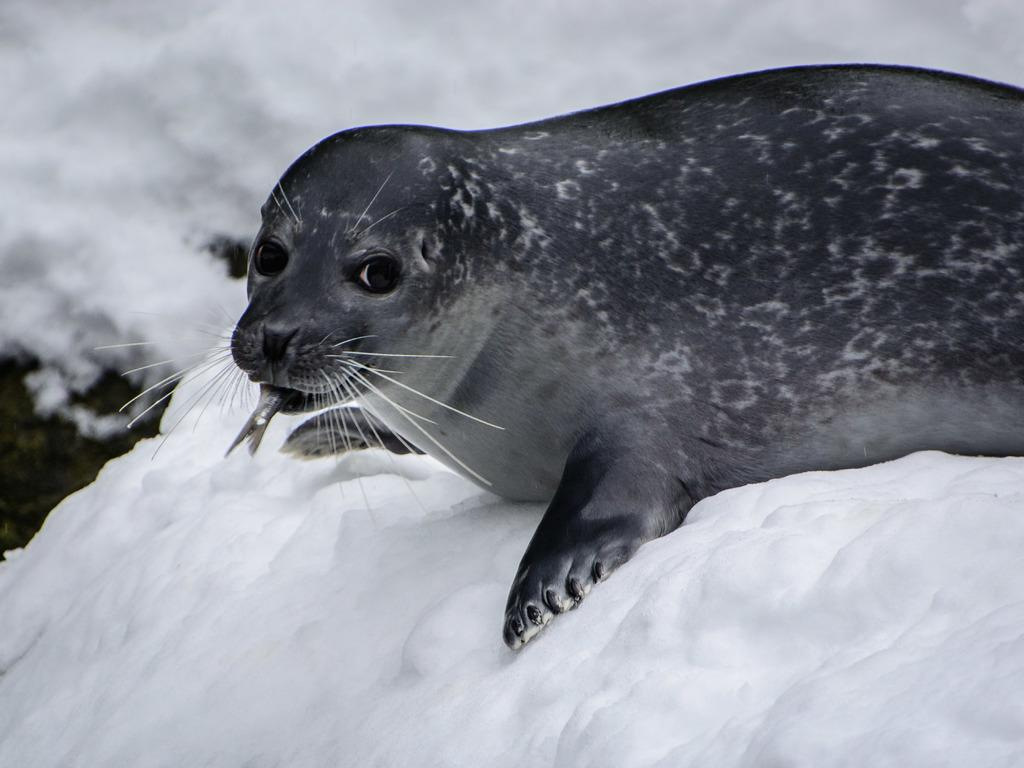What is the main subject of the picture? There is a seal in the middle of the picture. What is located at the bottom of the picture? There is ice at the bottom of the picture. What color is the background of the image? The background of the image is white in color. Is the image in color or black and white? The image is in black and white. Can you see a scarf being worn by the seal in the image? There is no scarf present in the image, and the seal is not wearing any clothing. What type of farm animals can be seen in the image? There are no farm animals present in the image; it features a seal on ice. 